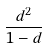<formula> <loc_0><loc_0><loc_500><loc_500>\frac { d ^ { 2 } } { 1 - d }</formula> 